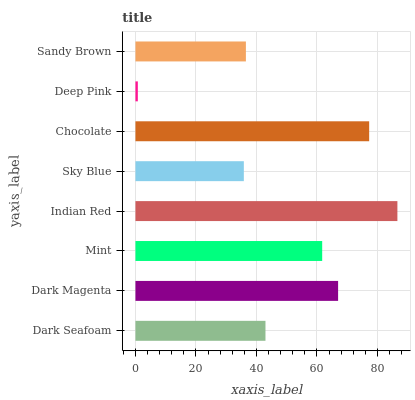Is Deep Pink the minimum?
Answer yes or no. Yes. Is Indian Red the maximum?
Answer yes or no. Yes. Is Dark Magenta the minimum?
Answer yes or no. No. Is Dark Magenta the maximum?
Answer yes or no. No. Is Dark Magenta greater than Dark Seafoam?
Answer yes or no. Yes. Is Dark Seafoam less than Dark Magenta?
Answer yes or no. Yes. Is Dark Seafoam greater than Dark Magenta?
Answer yes or no. No. Is Dark Magenta less than Dark Seafoam?
Answer yes or no. No. Is Mint the high median?
Answer yes or no. Yes. Is Dark Seafoam the low median?
Answer yes or no. Yes. Is Chocolate the high median?
Answer yes or no. No. Is Indian Red the low median?
Answer yes or no. No. 